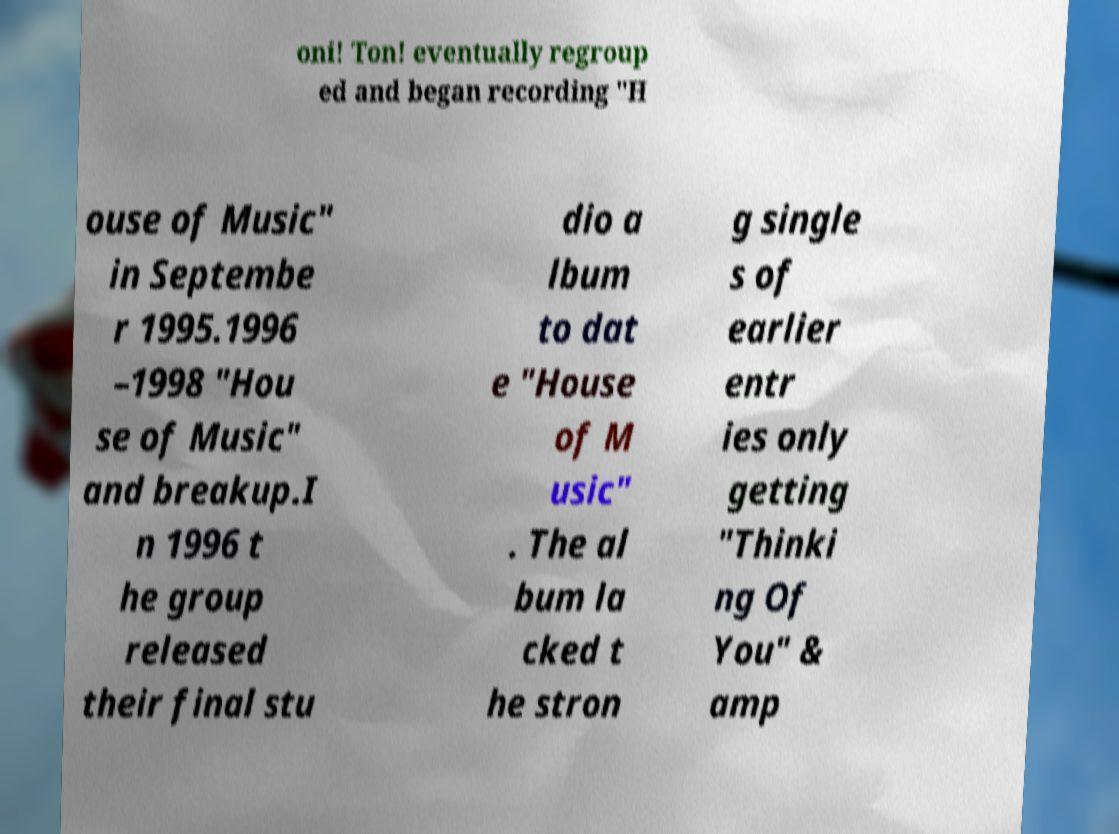I need the written content from this picture converted into text. Can you do that? oni! Ton! eventually regroup ed and began recording "H ouse of Music" in Septembe r 1995.1996 –1998 "Hou se of Music" and breakup.I n 1996 t he group released their final stu dio a lbum to dat e "House of M usic" . The al bum la cked t he stron g single s of earlier entr ies only getting "Thinki ng Of You" & amp 